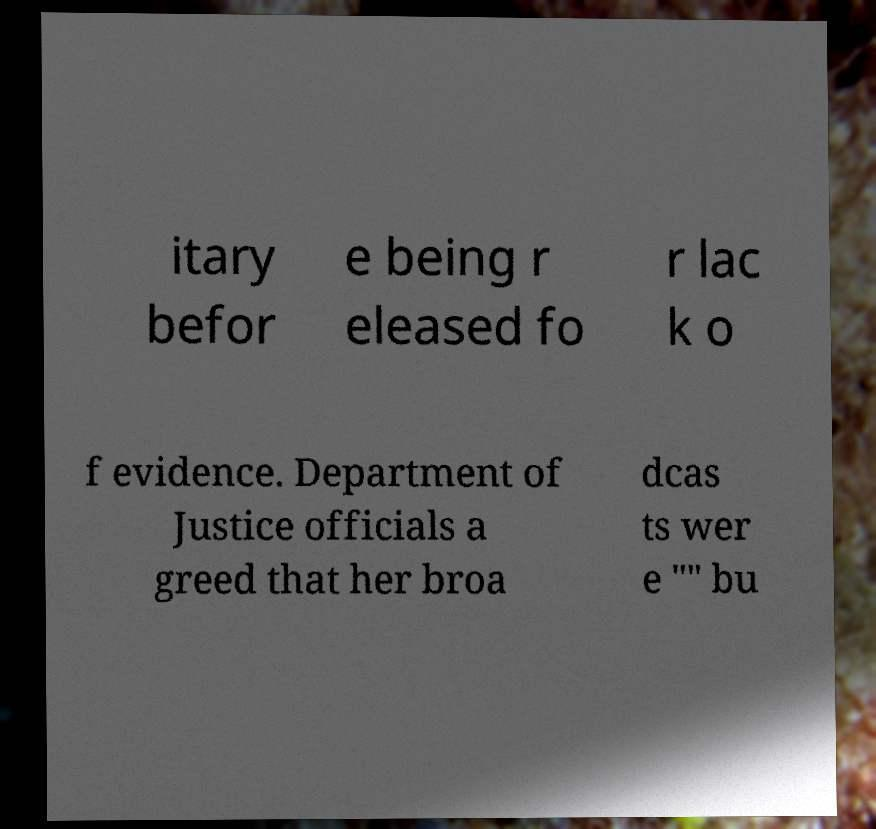Please read and relay the text visible in this image. What does it say? itary befor e being r eleased fo r lac k o f evidence. Department of Justice officials a greed that her broa dcas ts wer e "" bu 